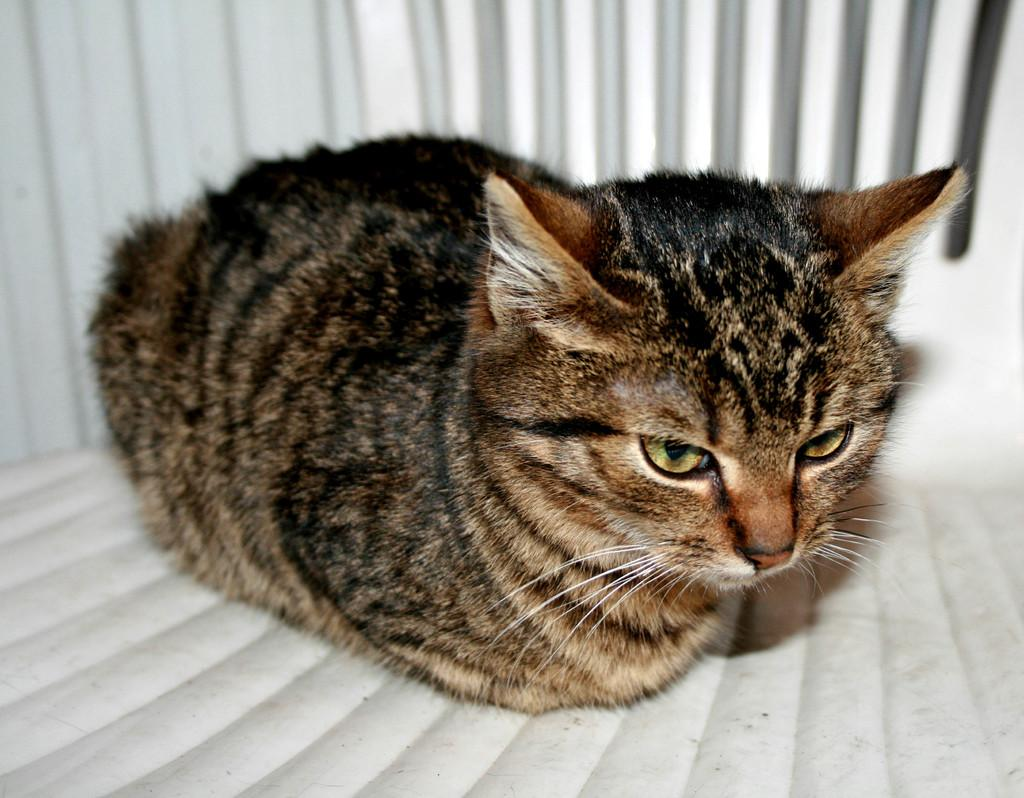What type of animal is in the image? There is a cat in the image. What can be seen behind the cat? The background of the image appears to be a wall. What type of behavior does the arch exhibit in the image? There is no arch present in the image, so it cannot exhibit any behavior. 